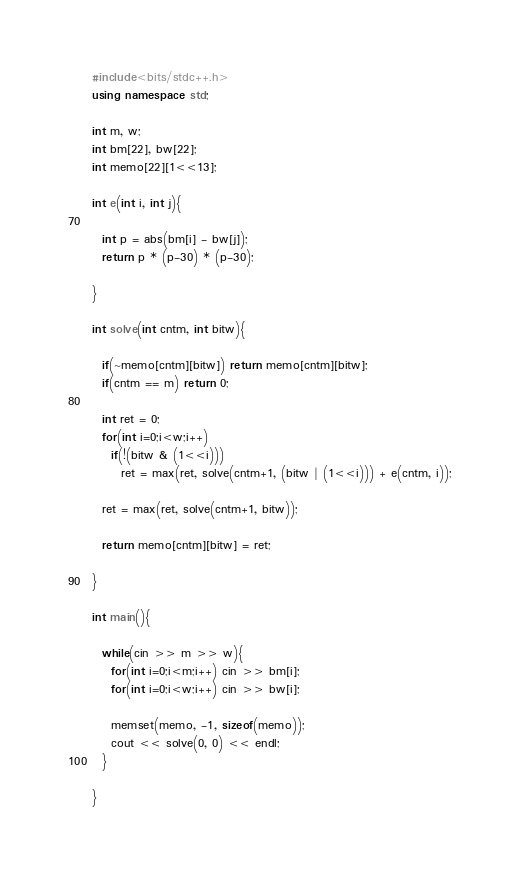<code> <loc_0><loc_0><loc_500><loc_500><_C++_>#include<bits/stdc++.h>
using namespace std;

int m, w;
int bm[22], bw[22];
int memo[22][1<<13];

int e(int i, int j){

  int p = abs(bm[i] - bw[j]);
  return p * (p-30) * (p-30);

}

int solve(int cntm, int bitw){

  if(~memo[cntm][bitw]) return memo[cntm][bitw];
  if(cntm == m) return 0;
  
  int ret = 0;
  for(int i=0;i<w;i++)
    if(!(bitw & (1<<i)))
      ret = max(ret, solve(cntm+1, (bitw | (1<<i))) + e(cntm, i));

  ret = max(ret, solve(cntm+1, bitw));
  
  return memo[cntm][bitw] = ret;
  
}

int main(){

  while(cin >> m >> w){
    for(int i=0;i<m;i++) cin >> bm[i];
    for(int i=0;i<w;i++) cin >> bw[i];
    
    memset(memo, -1, sizeof(memo));
    cout << solve(0, 0) << endl;
  }
  
}</code> 